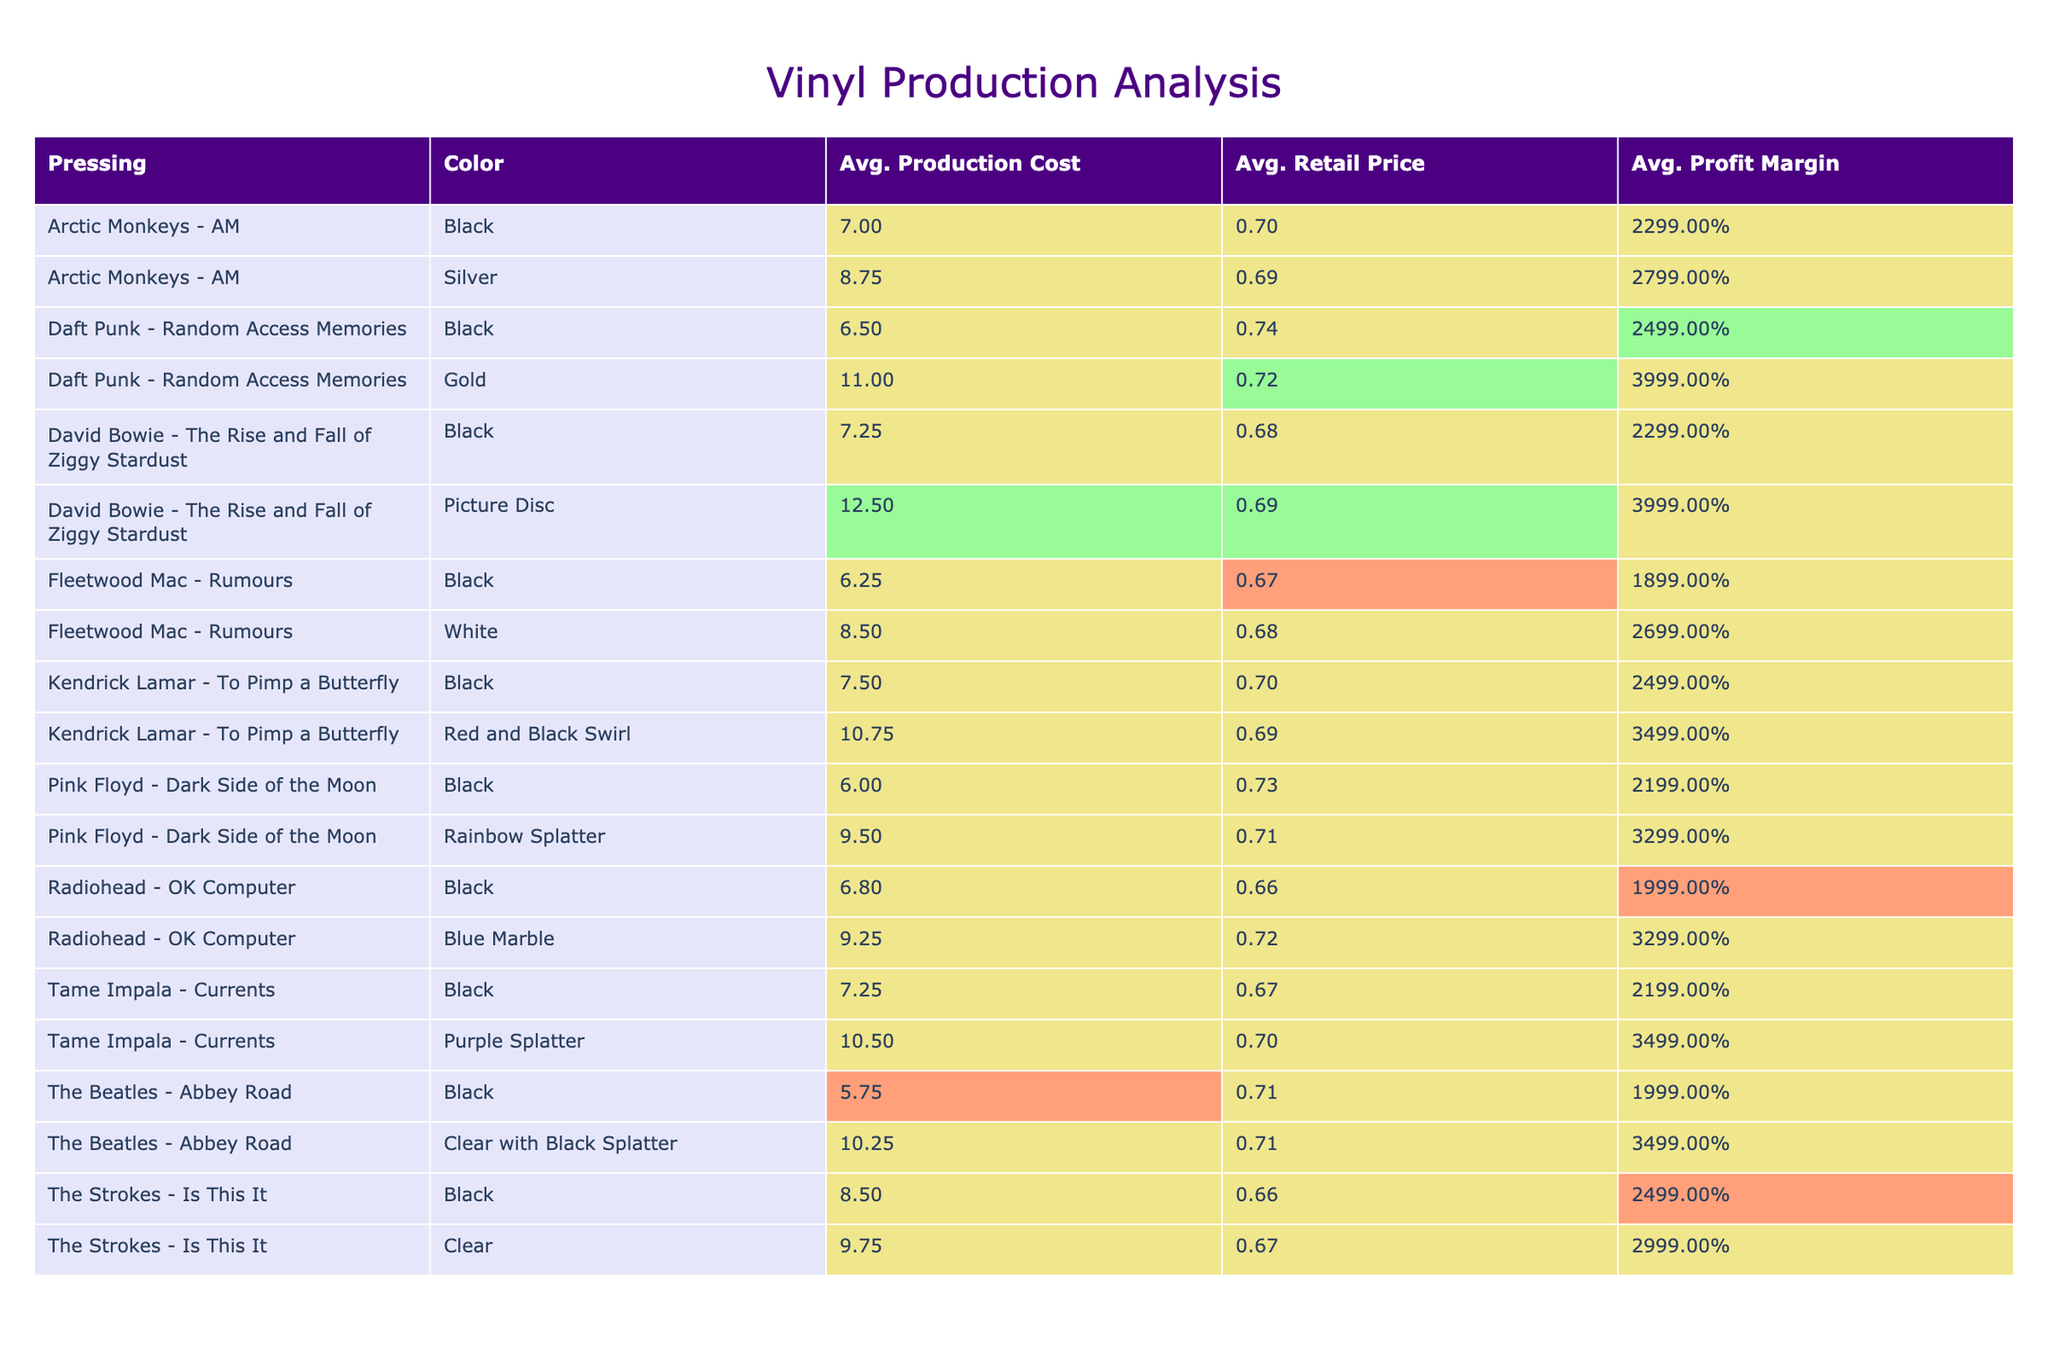What is the average production cost for the vinyl pressing of "The Strokes - Is This It"? For "The Strokes - Is This It", there are two color variants: Black with a production cost of 8.50 and Clear with a production cost of 9.75. To find the average, we sum the costs (8.50 + 9.75 = 18.25) and divide by the number of variants (2). Therefore, the average production cost is 18.25 / 2 = 9.125.
Answer: 9.12 Which vinyl pressing has the highest retail price? From the table, we look for the maximum value under the Retail Price column. The highest retail price is 39.99 for two pressings: Daft Punk - Random Access Memories (Gold) and David Bowie - The Rise and Fall of Ziggy Stardust (Picture Disc).
Answer: 39.99 Is the profit margin for the "Fleetwood Mac - Rumours" (White) variant greater than 0.70? The profit margin for "Fleetwood Mac - Rumours" (White) is 0.68. Since 0.68 is less than 0.70, the answer is no.
Answer: No What is the total production cost for all variants of "Kendrick Lamar - To Pimp a Butterfly"? The total production costs for its two variants are: Black (7.50) for a quantity of 4000 and Red and Black Swirl (10.75) for a quantity of 1500. Thus, the total production cost for all variants is (7.50 * 4000) + (10.75 * 1500) = 30000 + 16125 = 46125.
Answer: 46125 What is the profit margin range for all pressings? The profit margins range from a minimum of 0.66 (The Strokes - Is This It, Black) to a maximum of 0.74 (Daft Punk - Random Access Memories, Black). Thus, the range is 0.66 to 0.74.
Answer: 0.66 to 0.74 Which color variant of "Radiohead - OK Computer" has a higher average profit margin, Black or Blue Marble? The profit margin for "Radiohead - OK Computer" (Black) is 0.66, while the profit margin for (Blue Marble) is 0.72. Since 0.72 is greater than 0.66, Blue Marble has a higher average profit margin.
Answer: Blue Marble Among all vinyl pressings, which has the lowest average production cost? From examining the Production Cost column, we find that "The Beatles - Abbey Road" (Black) has the lowest average production cost at 5.75.
Answer: 5.75 What is the difference in retail prices between the Black and Clear variants of "The Strokes - Is This It"? The retail price for the Black variant is 24.99 and for the Clear variant, it is 29.99. The difference in retail prices is 29.99 - 24.99 = 5.00.
Answer: 5.00 